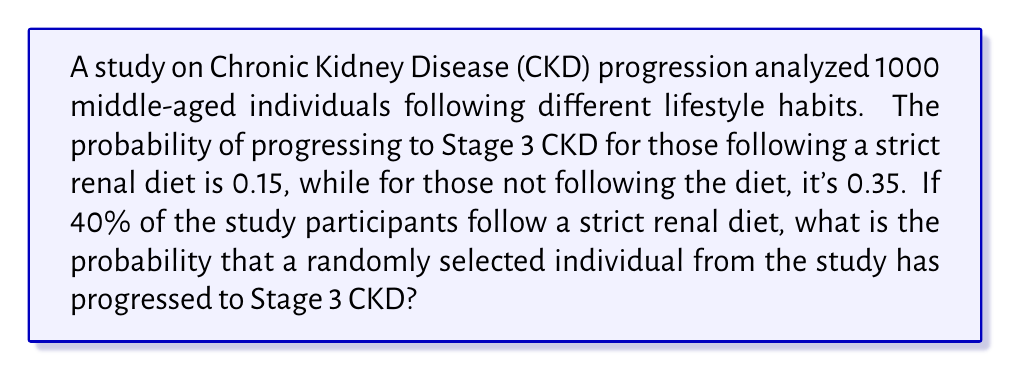What is the answer to this math problem? Let's approach this step-by-step using the law of total probability:

1) Define events:
   A: Following a strict renal diet
   B: Progressing to Stage 3 CKD

2) Given probabilities:
   $P(A) = 0.40$ (40% follow the diet)
   $P(B|A) = 0.15$ (probability of Stage 3 CKD given strict diet)
   $P(B|\text{not }A) = 0.35$ (probability of Stage 3 CKD without strict diet)

3) We need to find $P(B)$, which can be calculated using:
   $P(B) = P(B|A) \cdot P(A) + P(B|\text{not }A) \cdot P(\text{not }A)$

4) Calculate $P(\text{not }A)$:
   $P(\text{not }A) = 1 - P(A) = 1 - 0.40 = 0.60$

5) Now, let's substitute into the formula:
   $P(B) = 0.15 \cdot 0.40 + 0.35 \cdot 0.60$

6) Calculate:
   $P(B) = 0.06 + 0.21 = 0.27$

Therefore, the probability that a randomly selected individual from the study has progressed to Stage 3 CKD is 0.27 or 27%.
Answer: 0.27 